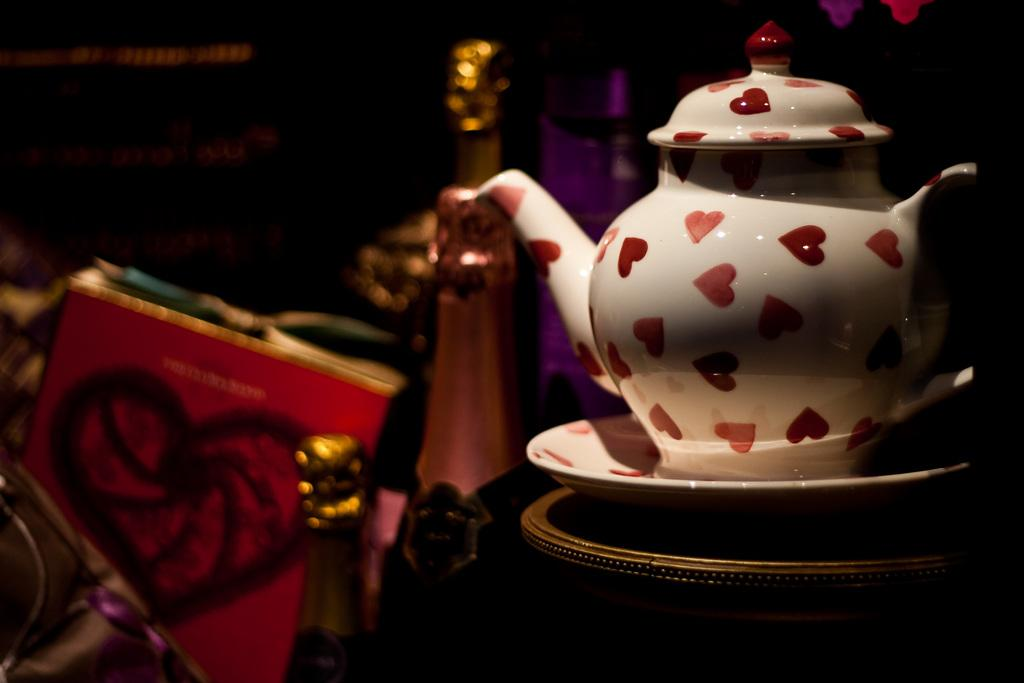What is the dog playing with in the image? The dog is playing with a ball in the image. What color is the dog in the image? The dog is brown in color. Is there any other animal present in the image? No, there is no other animal present in the image. What type of beef is the dog eating in the image? There is no beef present in the image; the dog is playing with a ball. 